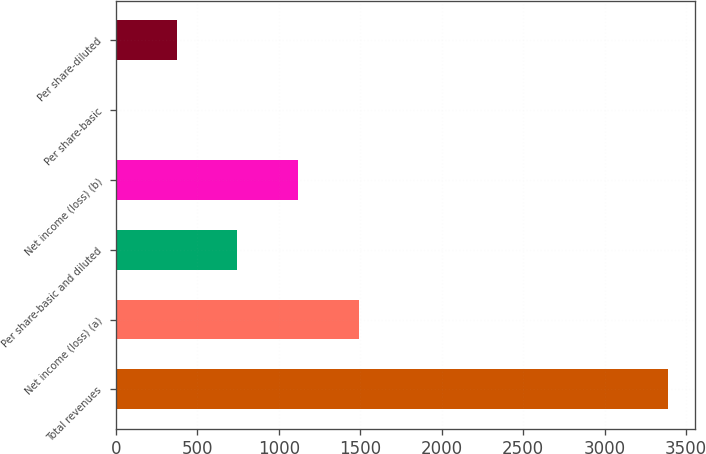Convert chart to OTSL. <chart><loc_0><loc_0><loc_500><loc_500><bar_chart><fcel>Total revenues<fcel>Net income (loss) (a)<fcel>Per share-basic and diluted<fcel>Net income (loss) (b)<fcel>Per share-basic<fcel>Per share-diluted<nl><fcel>3388<fcel>1490.1<fcel>745.12<fcel>1117.61<fcel>0.14<fcel>372.63<nl></chart> 